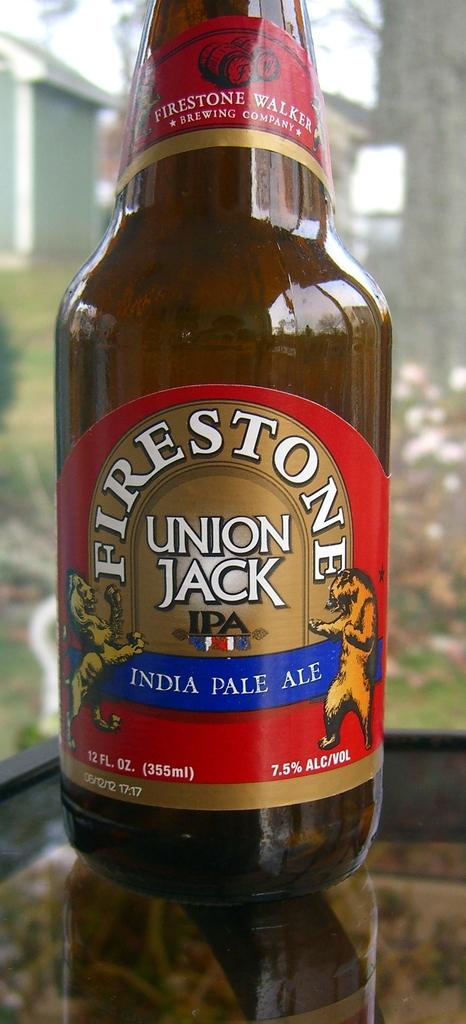<image>
Give a short and clear explanation of the subsequent image. A bottle of Indian Pale Ale made by Firestone. 